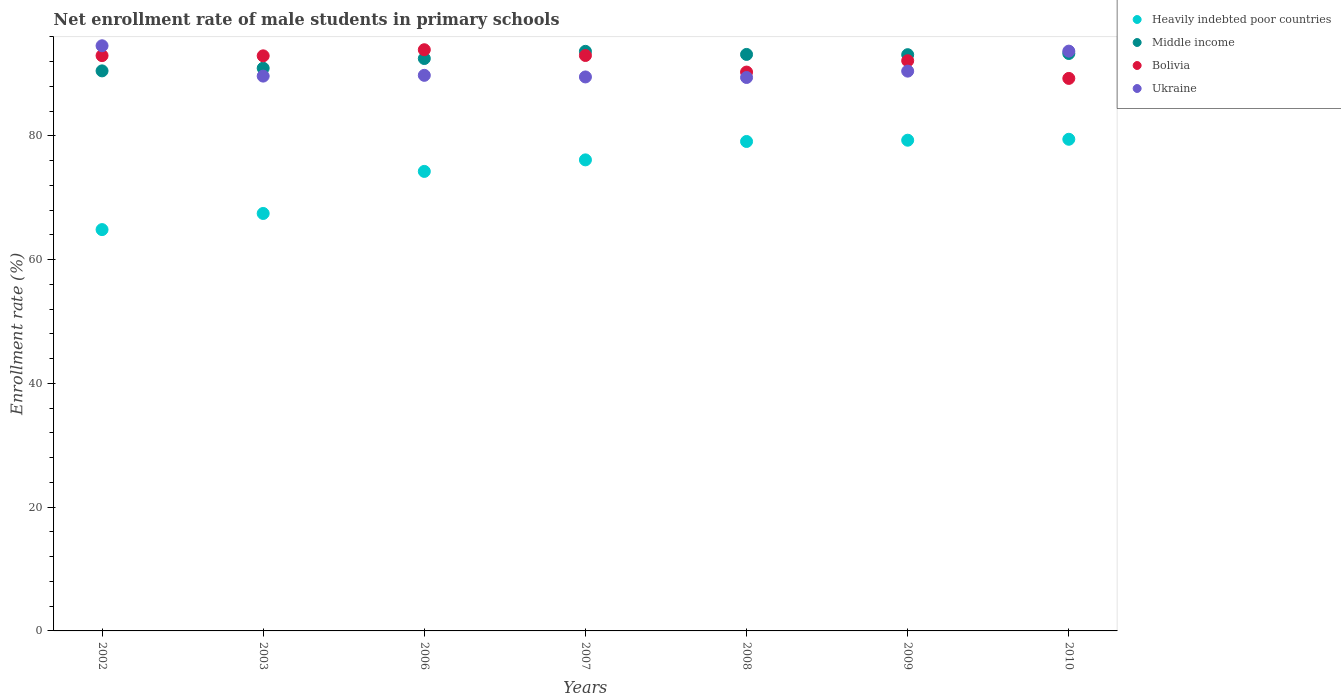How many different coloured dotlines are there?
Provide a succinct answer. 4. What is the net enrollment rate of male students in primary schools in Middle income in 2006?
Provide a short and direct response. 92.52. Across all years, what is the maximum net enrollment rate of male students in primary schools in Heavily indebted poor countries?
Your answer should be very brief. 79.46. Across all years, what is the minimum net enrollment rate of male students in primary schools in Heavily indebted poor countries?
Make the answer very short. 64.86. In which year was the net enrollment rate of male students in primary schools in Heavily indebted poor countries maximum?
Provide a succinct answer. 2010. What is the total net enrollment rate of male students in primary schools in Middle income in the graph?
Keep it short and to the point. 647.29. What is the difference between the net enrollment rate of male students in primary schools in Middle income in 2007 and that in 2008?
Your response must be concise. 0.5. What is the difference between the net enrollment rate of male students in primary schools in Ukraine in 2006 and the net enrollment rate of male students in primary schools in Bolivia in 2003?
Your response must be concise. -3.15. What is the average net enrollment rate of male students in primary schools in Bolivia per year?
Keep it short and to the point. 92.09. In the year 2006, what is the difference between the net enrollment rate of male students in primary schools in Heavily indebted poor countries and net enrollment rate of male students in primary schools in Middle income?
Offer a very short reply. -18.25. What is the ratio of the net enrollment rate of male students in primary schools in Middle income in 2009 to that in 2010?
Keep it short and to the point. 1. Is the net enrollment rate of male students in primary schools in Middle income in 2007 less than that in 2010?
Offer a very short reply. No. What is the difference between the highest and the second highest net enrollment rate of male students in primary schools in Bolivia?
Offer a very short reply. 0.93. What is the difference between the highest and the lowest net enrollment rate of male students in primary schools in Heavily indebted poor countries?
Provide a succinct answer. 14.6. In how many years, is the net enrollment rate of male students in primary schools in Middle income greater than the average net enrollment rate of male students in primary schools in Middle income taken over all years?
Offer a very short reply. 5. Is the sum of the net enrollment rate of male students in primary schools in Ukraine in 2002 and 2009 greater than the maximum net enrollment rate of male students in primary schools in Middle income across all years?
Offer a very short reply. Yes. Is it the case that in every year, the sum of the net enrollment rate of male students in primary schools in Middle income and net enrollment rate of male students in primary schools in Ukraine  is greater than the sum of net enrollment rate of male students in primary schools in Bolivia and net enrollment rate of male students in primary schools in Heavily indebted poor countries?
Offer a terse response. No. Is the net enrollment rate of male students in primary schools in Bolivia strictly less than the net enrollment rate of male students in primary schools in Middle income over the years?
Give a very brief answer. No. How many dotlines are there?
Your response must be concise. 4. What is the difference between two consecutive major ticks on the Y-axis?
Offer a very short reply. 20. Are the values on the major ticks of Y-axis written in scientific E-notation?
Your answer should be very brief. No. Does the graph contain grids?
Offer a very short reply. No. Where does the legend appear in the graph?
Provide a short and direct response. Top right. How many legend labels are there?
Your answer should be compact. 4. How are the legend labels stacked?
Keep it short and to the point. Vertical. What is the title of the graph?
Offer a terse response. Net enrollment rate of male students in primary schools. Does "Bolivia" appear as one of the legend labels in the graph?
Your answer should be compact. Yes. What is the label or title of the Y-axis?
Your answer should be very brief. Enrollment rate (%). What is the Enrollment rate (%) in Heavily indebted poor countries in 2002?
Your response must be concise. 64.86. What is the Enrollment rate (%) of Middle income in 2002?
Offer a terse response. 90.52. What is the Enrollment rate (%) of Bolivia in 2002?
Ensure brevity in your answer.  92.98. What is the Enrollment rate (%) of Ukraine in 2002?
Keep it short and to the point. 94.58. What is the Enrollment rate (%) in Heavily indebted poor countries in 2003?
Your answer should be compact. 67.47. What is the Enrollment rate (%) in Middle income in 2003?
Make the answer very short. 90.95. What is the Enrollment rate (%) in Bolivia in 2003?
Offer a very short reply. 92.95. What is the Enrollment rate (%) in Ukraine in 2003?
Make the answer very short. 89.67. What is the Enrollment rate (%) of Heavily indebted poor countries in 2006?
Your answer should be very brief. 74.27. What is the Enrollment rate (%) in Middle income in 2006?
Provide a succinct answer. 92.52. What is the Enrollment rate (%) in Bolivia in 2006?
Keep it short and to the point. 93.94. What is the Enrollment rate (%) in Ukraine in 2006?
Provide a short and direct response. 89.8. What is the Enrollment rate (%) in Heavily indebted poor countries in 2007?
Offer a very short reply. 76.13. What is the Enrollment rate (%) in Middle income in 2007?
Ensure brevity in your answer.  93.67. What is the Enrollment rate (%) in Bolivia in 2007?
Provide a short and direct response. 93.01. What is the Enrollment rate (%) of Ukraine in 2007?
Provide a succinct answer. 89.54. What is the Enrollment rate (%) of Heavily indebted poor countries in 2008?
Offer a terse response. 79.11. What is the Enrollment rate (%) of Middle income in 2008?
Ensure brevity in your answer.  93.18. What is the Enrollment rate (%) in Bolivia in 2008?
Provide a succinct answer. 90.33. What is the Enrollment rate (%) in Ukraine in 2008?
Make the answer very short. 89.45. What is the Enrollment rate (%) of Heavily indebted poor countries in 2009?
Make the answer very short. 79.31. What is the Enrollment rate (%) in Middle income in 2009?
Offer a very short reply. 93.14. What is the Enrollment rate (%) in Bolivia in 2009?
Your answer should be compact. 92.16. What is the Enrollment rate (%) of Ukraine in 2009?
Provide a succinct answer. 90.48. What is the Enrollment rate (%) in Heavily indebted poor countries in 2010?
Your answer should be compact. 79.46. What is the Enrollment rate (%) of Middle income in 2010?
Offer a very short reply. 93.33. What is the Enrollment rate (%) of Bolivia in 2010?
Provide a succinct answer. 89.3. What is the Enrollment rate (%) of Ukraine in 2010?
Keep it short and to the point. 93.71. Across all years, what is the maximum Enrollment rate (%) of Heavily indebted poor countries?
Your answer should be compact. 79.46. Across all years, what is the maximum Enrollment rate (%) of Middle income?
Provide a succinct answer. 93.67. Across all years, what is the maximum Enrollment rate (%) in Bolivia?
Make the answer very short. 93.94. Across all years, what is the maximum Enrollment rate (%) of Ukraine?
Offer a very short reply. 94.58. Across all years, what is the minimum Enrollment rate (%) in Heavily indebted poor countries?
Your answer should be very brief. 64.86. Across all years, what is the minimum Enrollment rate (%) in Middle income?
Offer a very short reply. 90.52. Across all years, what is the minimum Enrollment rate (%) of Bolivia?
Your answer should be very brief. 89.3. Across all years, what is the minimum Enrollment rate (%) of Ukraine?
Offer a very short reply. 89.45. What is the total Enrollment rate (%) of Heavily indebted poor countries in the graph?
Make the answer very short. 520.62. What is the total Enrollment rate (%) of Middle income in the graph?
Offer a very short reply. 647.29. What is the total Enrollment rate (%) in Bolivia in the graph?
Keep it short and to the point. 644.66. What is the total Enrollment rate (%) of Ukraine in the graph?
Keep it short and to the point. 637.22. What is the difference between the Enrollment rate (%) of Heavily indebted poor countries in 2002 and that in 2003?
Provide a short and direct response. -2.61. What is the difference between the Enrollment rate (%) of Middle income in 2002 and that in 2003?
Your answer should be compact. -0.43. What is the difference between the Enrollment rate (%) in Bolivia in 2002 and that in 2003?
Your response must be concise. 0.03. What is the difference between the Enrollment rate (%) of Ukraine in 2002 and that in 2003?
Offer a very short reply. 4.9. What is the difference between the Enrollment rate (%) in Heavily indebted poor countries in 2002 and that in 2006?
Offer a very short reply. -9.41. What is the difference between the Enrollment rate (%) of Middle income in 2002 and that in 2006?
Offer a terse response. -2. What is the difference between the Enrollment rate (%) in Bolivia in 2002 and that in 2006?
Your response must be concise. -0.95. What is the difference between the Enrollment rate (%) of Ukraine in 2002 and that in 2006?
Provide a short and direct response. 4.78. What is the difference between the Enrollment rate (%) of Heavily indebted poor countries in 2002 and that in 2007?
Ensure brevity in your answer.  -11.27. What is the difference between the Enrollment rate (%) in Middle income in 2002 and that in 2007?
Provide a succinct answer. -3.16. What is the difference between the Enrollment rate (%) in Bolivia in 2002 and that in 2007?
Your answer should be compact. -0.02. What is the difference between the Enrollment rate (%) in Ukraine in 2002 and that in 2007?
Keep it short and to the point. 5.04. What is the difference between the Enrollment rate (%) of Heavily indebted poor countries in 2002 and that in 2008?
Keep it short and to the point. -14.24. What is the difference between the Enrollment rate (%) of Middle income in 2002 and that in 2008?
Provide a short and direct response. -2.66. What is the difference between the Enrollment rate (%) of Bolivia in 2002 and that in 2008?
Your response must be concise. 2.66. What is the difference between the Enrollment rate (%) of Ukraine in 2002 and that in 2008?
Make the answer very short. 5.13. What is the difference between the Enrollment rate (%) of Heavily indebted poor countries in 2002 and that in 2009?
Ensure brevity in your answer.  -14.45. What is the difference between the Enrollment rate (%) of Middle income in 2002 and that in 2009?
Your response must be concise. -2.62. What is the difference between the Enrollment rate (%) in Bolivia in 2002 and that in 2009?
Offer a terse response. 0.82. What is the difference between the Enrollment rate (%) of Ukraine in 2002 and that in 2009?
Make the answer very short. 4.1. What is the difference between the Enrollment rate (%) in Heavily indebted poor countries in 2002 and that in 2010?
Give a very brief answer. -14.6. What is the difference between the Enrollment rate (%) in Middle income in 2002 and that in 2010?
Your response must be concise. -2.81. What is the difference between the Enrollment rate (%) in Bolivia in 2002 and that in 2010?
Make the answer very short. 3.68. What is the difference between the Enrollment rate (%) of Ukraine in 2002 and that in 2010?
Your answer should be compact. 0.87. What is the difference between the Enrollment rate (%) in Heavily indebted poor countries in 2003 and that in 2006?
Keep it short and to the point. -6.8. What is the difference between the Enrollment rate (%) in Middle income in 2003 and that in 2006?
Provide a short and direct response. -1.57. What is the difference between the Enrollment rate (%) of Bolivia in 2003 and that in 2006?
Provide a succinct answer. -0.99. What is the difference between the Enrollment rate (%) in Ukraine in 2003 and that in 2006?
Make the answer very short. -0.13. What is the difference between the Enrollment rate (%) in Heavily indebted poor countries in 2003 and that in 2007?
Make the answer very short. -8.66. What is the difference between the Enrollment rate (%) of Middle income in 2003 and that in 2007?
Your response must be concise. -2.73. What is the difference between the Enrollment rate (%) in Bolivia in 2003 and that in 2007?
Your response must be concise. -0.06. What is the difference between the Enrollment rate (%) of Ukraine in 2003 and that in 2007?
Provide a succinct answer. 0.14. What is the difference between the Enrollment rate (%) in Heavily indebted poor countries in 2003 and that in 2008?
Provide a short and direct response. -11.63. What is the difference between the Enrollment rate (%) in Middle income in 2003 and that in 2008?
Ensure brevity in your answer.  -2.23. What is the difference between the Enrollment rate (%) in Bolivia in 2003 and that in 2008?
Offer a very short reply. 2.62. What is the difference between the Enrollment rate (%) of Ukraine in 2003 and that in 2008?
Give a very brief answer. 0.22. What is the difference between the Enrollment rate (%) of Heavily indebted poor countries in 2003 and that in 2009?
Your response must be concise. -11.84. What is the difference between the Enrollment rate (%) of Middle income in 2003 and that in 2009?
Your answer should be very brief. -2.19. What is the difference between the Enrollment rate (%) of Bolivia in 2003 and that in 2009?
Ensure brevity in your answer.  0.79. What is the difference between the Enrollment rate (%) in Ukraine in 2003 and that in 2009?
Ensure brevity in your answer.  -0.8. What is the difference between the Enrollment rate (%) in Heavily indebted poor countries in 2003 and that in 2010?
Offer a very short reply. -11.99. What is the difference between the Enrollment rate (%) of Middle income in 2003 and that in 2010?
Provide a short and direct response. -2.38. What is the difference between the Enrollment rate (%) of Bolivia in 2003 and that in 2010?
Provide a short and direct response. 3.65. What is the difference between the Enrollment rate (%) in Ukraine in 2003 and that in 2010?
Give a very brief answer. -4.04. What is the difference between the Enrollment rate (%) of Heavily indebted poor countries in 2006 and that in 2007?
Offer a very short reply. -1.86. What is the difference between the Enrollment rate (%) in Middle income in 2006 and that in 2007?
Offer a very short reply. -1.16. What is the difference between the Enrollment rate (%) in Bolivia in 2006 and that in 2007?
Offer a terse response. 0.93. What is the difference between the Enrollment rate (%) of Ukraine in 2006 and that in 2007?
Your response must be concise. 0.26. What is the difference between the Enrollment rate (%) of Heavily indebted poor countries in 2006 and that in 2008?
Offer a very short reply. -4.84. What is the difference between the Enrollment rate (%) in Middle income in 2006 and that in 2008?
Your response must be concise. -0.66. What is the difference between the Enrollment rate (%) of Bolivia in 2006 and that in 2008?
Provide a succinct answer. 3.61. What is the difference between the Enrollment rate (%) in Ukraine in 2006 and that in 2008?
Your answer should be compact. 0.35. What is the difference between the Enrollment rate (%) in Heavily indebted poor countries in 2006 and that in 2009?
Offer a very short reply. -5.04. What is the difference between the Enrollment rate (%) in Middle income in 2006 and that in 2009?
Your answer should be very brief. -0.62. What is the difference between the Enrollment rate (%) in Bolivia in 2006 and that in 2009?
Offer a terse response. 1.78. What is the difference between the Enrollment rate (%) in Ukraine in 2006 and that in 2009?
Ensure brevity in your answer.  -0.68. What is the difference between the Enrollment rate (%) in Heavily indebted poor countries in 2006 and that in 2010?
Offer a terse response. -5.2. What is the difference between the Enrollment rate (%) in Middle income in 2006 and that in 2010?
Make the answer very short. -0.81. What is the difference between the Enrollment rate (%) of Bolivia in 2006 and that in 2010?
Your response must be concise. 4.63. What is the difference between the Enrollment rate (%) in Ukraine in 2006 and that in 2010?
Make the answer very short. -3.91. What is the difference between the Enrollment rate (%) of Heavily indebted poor countries in 2007 and that in 2008?
Your answer should be compact. -2.97. What is the difference between the Enrollment rate (%) in Middle income in 2007 and that in 2008?
Make the answer very short. 0.5. What is the difference between the Enrollment rate (%) of Bolivia in 2007 and that in 2008?
Give a very brief answer. 2.68. What is the difference between the Enrollment rate (%) in Ukraine in 2007 and that in 2008?
Ensure brevity in your answer.  0.09. What is the difference between the Enrollment rate (%) of Heavily indebted poor countries in 2007 and that in 2009?
Ensure brevity in your answer.  -3.18. What is the difference between the Enrollment rate (%) of Middle income in 2007 and that in 2009?
Ensure brevity in your answer.  0.54. What is the difference between the Enrollment rate (%) of Bolivia in 2007 and that in 2009?
Give a very brief answer. 0.84. What is the difference between the Enrollment rate (%) in Ukraine in 2007 and that in 2009?
Make the answer very short. -0.94. What is the difference between the Enrollment rate (%) of Heavily indebted poor countries in 2007 and that in 2010?
Your response must be concise. -3.33. What is the difference between the Enrollment rate (%) in Middle income in 2007 and that in 2010?
Your response must be concise. 0.35. What is the difference between the Enrollment rate (%) of Bolivia in 2007 and that in 2010?
Give a very brief answer. 3.7. What is the difference between the Enrollment rate (%) of Ukraine in 2007 and that in 2010?
Offer a very short reply. -4.17. What is the difference between the Enrollment rate (%) of Heavily indebted poor countries in 2008 and that in 2009?
Provide a succinct answer. -0.21. What is the difference between the Enrollment rate (%) of Middle income in 2008 and that in 2009?
Your answer should be very brief. 0.04. What is the difference between the Enrollment rate (%) of Bolivia in 2008 and that in 2009?
Provide a short and direct response. -1.84. What is the difference between the Enrollment rate (%) of Ukraine in 2008 and that in 2009?
Keep it short and to the point. -1.03. What is the difference between the Enrollment rate (%) of Heavily indebted poor countries in 2008 and that in 2010?
Your answer should be compact. -0.36. What is the difference between the Enrollment rate (%) of Middle income in 2008 and that in 2010?
Provide a succinct answer. -0.15. What is the difference between the Enrollment rate (%) in Bolivia in 2008 and that in 2010?
Provide a short and direct response. 1.02. What is the difference between the Enrollment rate (%) of Ukraine in 2008 and that in 2010?
Ensure brevity in your answer.  -4.26. What is the difference between the Enrollment rate (%) in Heavily indebted poor countries in 2009 and that in 2010?
Offer a terse response. -0.15. What is the difference between the Enrollment rate (%) of Middle income in 2009 and that in 2010?
Make the answer very short. -0.19. What is the difference between the Enrollment rate (%) in Bolivia in 2009 and that in 2010?
Ensure brevity in your answer.  2.86. What is the difference between the Enrollment rate (%) in Ukraine in 2009 and that in 2010?
Provide a succinct answer. -3.23. What is the difference between the Enrollment rate (%) of Heavily indebted poor countries in 2002 and the Enrollment rate (%) of Middle income in 2003?
Provide a succinct answer. -26.08. What is the difference between the Enrollment rate (%) in Heavily indebted poor countries in 2002 and the Enrollment rate (%) in Bolivia in 2003?
Your answer should be compact. -28.08. What is the difference between the Enrollment rate (%) of Heavily indebted poor countries in 2002 and the Enrollment rate (%) of Ukraine in 2003?
Give a very brief answer. -24.81. What is the difference between the Enrollment rate (%) of Middle income in 2002 and the Enrollment rate (%) of Bolivia in 2003?
Make the answer very short. -2.43. What is the difference between the Enrollment rate (%) in Middle income in 2002 and the Enrollment rate (%) in Ukraine in 2003?
Your answer should be very brief. 0.84. What is the difference between the Enrollment rate (%) of Bolivia in 2002 and the Enrollment rate (%) of Ukraine in 2003?
Make the answer very short. 3.31. What is the difference between the Enrollment rate (%) in Heavily indebted poor countries in 2002 and the Enrollment rate (%) in Middle income in 2006?
Offer a very short reply. -27.65. What is the difference between the Enrollment rate (%) of Heavily indebted poor countries in 2002 and the Enrollment rate (%) of Bolivia in 2006?
Give a very brief answer. -29.07. What is the difference between the Enrollment rate (%) in Heavily indebted poor countries in 2002 and the Enrollment rate (%) in Ukraine in 2006?
Provide a succinct answer. -24.93. What is the difference between the Enrollment rate (%) of Middle income in 2002 and the Enrollment rate (%) of Bolivia in 2006?
Provide a short and direct response. -3.42. What is the difference between the Enrollment rate (%) of Middle income in 2002 and the Enrollment rate (%) of Ukraine in 2006?
Offer a terse response. 0.72. What is the difference between the Enrollment rate (%) in Bolivia in 2002 and the Enrollment rate (%) in Ukraine in 2006?
Provide a short and direct response. 3.18. What is the difference between the Enrollment rate (%) in Heavily indebted poor countries in 2002 and the Enrollment rate (%) in Middle income in 2007?
Make the answer very short. -28.81. What is the difference between the Enrollment rate (%) of Heavily indebted poor countries in 2002 and the Enrollment rate (%) of Bolivia in 2007?
Keep it short and to the point. -28.14. What is the difference between the Enrollment rate (%) in Heavily indebted poor countries in 2002 and the Enrollment rate (%) in Ukraine in 2007?
Provide a succinct answer. -24.67. What is the difference between the Enrollment rate (%) of Middle income in 2002 and the Enrollment rate (%) of Bolivia in 2007?
Ensure brevity in your answer.  -2.49. What is the difference between the Enrollment rate (%) of Middle income in 2002 and the Enrollment rate (%) of Ukraine in 2007?
Offer a very short reply. 0.98. What is the difference between the Enrollment rate (%) of Bolivia in 2002 and the Enrollment rate (%) of Ukraine in 2007?
Provide a succinct answer. 3.44. What is the difference between the Enrollment rate (%) in Heavily indebted poor countries in 2002 and the Enrollment rate (%) in Middle income in 2008?
Provide a succinct answer. -28.31. What is the difference between the Enrollment rate (%) in Heavily indebted poor countries in 2002 and the Enrollment rate (%) in Bolivia in 2008?
Provide a succinct answer. -25.46. What is the difference between the Enrollment rate (%) in Heavily indebted poor countries in 2002 and the Enrollment rate (%) in Ukraine in 2008?
Offer a very short reply. -24.59. What is the difference between the Enrollment rate (%) in Middle income in 2002 and the Enrollment rate (%) in Bolivia in 2008?
Give a very brief answer. 0.19. What is the difference between the Enrollment rate (%) in Middle income in 2002 and the Enrollment rate (%) in Ukraine in 2008?
Your answer should be compact. 1.07. What is the difference between the Enrollment rate (%) of Bolivia in 2002 and the Enrollment rate (%) of Ukraine in 2008?
Make the answer very short. 3.53. What is the difference between the Enrollment rate (%) in Heavily indebted poor countries in 2002 and the Enrollment rate (%) in Middle income in 2009?
Your answer should be compact. -28.27. What is the difference between the Enrollment rate (%) in Heavily indebted poor countries in 2002 and the Enrollment rate (%) in Bolivia in 2009?
Keep it short and to the point. -27.3. What is the difference between the Enrollment rate (%) in Heavily indebted poor countries in 2002 and the Enrollment rate (%) in Ukraine in 2009?
Your response must be concise. -25.61. What is the difference between the Enrollment rate (%) in Middle income in 2002 and the Enrollment rate (%) in Bolivia in 2009?
Make the answer very short. -1.64. What is the difference between the Enrollment rate (%) of Middle income in 2002 and the Enrollment rate (%) of Ukraine in 2009?
Your response must be concise. 0.04. What is the difference between the Enrollment rate (%) in Bolivia in 2002 and the Enrollment rate (%) in Ukraine in 2009?
Ensure brevity in your answer.  2.5. What is the difference between the Enrollment rate (%) of Heavily indebted poor countries in 2002 and the Enrollment rate (%) of Middle income in 2010?
Make the answer very short. -28.46. What is the difference between the Enrollment rate (%) in Heavily indebted poor countries in 2002 and the Enrollment rate (%) in Bolivia in 2010?
Provide a succinct answer. -24.44. What is the difference between the Enrollment rate (%) of Heavily indebted poor countries in 2002 and the Enrollment rate (%) of Ukraine in 2010?
Provide a short and direct response. -28.85. What is the difference between the Enrollment rate (%) of Middle income in 2002 and the Enrollment rate (%) of Bolivia in 2010?
Offer a terse response. 1.22. What is the difference between the Enrollment rate (%) in Middle income in 2002 and the Enrollment rate (%) in Ukraine in 2010?
Your answer should be compact. -3.19. What is the difference between the Enrollment rate (%) in Bolivia in 2002 and the Enrollment rate (%) in Ukraine in 2010?
Your response must be concise. -0.73. What is the difference between the Enrollment rate (%) in Heavily indebted poor countries in 2003 and the Enrollment rate (%) in Middle income in 2006?
Offer a terse response. -25.04. What is the difference between the Enrollment rate (%) in Heavily indebted poor countries in 2003 and the Enrollment rate (%) in Bolivia in 2006?
Provide a succinct answer. -26.46. What is the difference between the Enrollment rate (%) of Heavily indebted poor countries in 2003 and the Enrollment rate (%) of Ukraine in 2006?
Offer a very short reply. -22.33. What is the difference between the Enrollment rate (%) of Middle income in 2003 and the Enrollment rate (%) of Bolivia in 2006?
Your response must be concise. -2.99. What is the difference between the Enrollment rate (%) in Middle income in 2003 and the Enrollment rate (%) in Ukraine in 2006?
Offer a very short reply. 1.15. What is the difference between the Enrollment rate (%) of Bolivia in 2003 and the Enrollment rate (%) of Ukraine in 2006?
Give a very brief answer. 3.15. What is the difference between the Enrollment rate (%) in Heavily indebted poor countries in 2003 and the Enrollment rate (%) in Middle income in 2007?
Your answer should be compact. -26.2. What is the difference between the Enrollment rate (%) of Heavily indebted poor countries in 2003 and the Enrollment rate (%) of Bolivia in 2007?
Your answer should be compact. -25.53. What is the difference between the Enrollment rate (%) in Heavily indebted poor countries in 2003 and the Enrollment rate (%) in Ukraine in 2007?
Your answer should be compact. -22.07. What is the difference between the Enrollment rate (%) in Middle income in 2003 and the Enrollment rate (%) in Bolivia in 2007?
Keep it short and to the point. -2.06. What is the difference between the Enrollment rate (%) of Middle income in 2003 and the Enrollment rate (%) of Ukraine in 2007?
Provide a succinct answer. 1.41. What is the difference between the Enrollment rate (%) in Bolivia in 2003 and the Enrollment rate (%) in Ukraine in 2007?
Offer a terse response. 3.41. What is the difference between the Enrollment rate (%) of Heavily indebted poor countries in 2003 and the Enrollment rate (%) of Middle income in 2008?
Give a very brief answer. -25.71. What is the difference between the Enrollment rate (%) of Heavily indebted poor countries in 2003 and the Enrollment rate (%) of Bolivia in 2008?
Your response must be concise. -22.85. What is the difference between the Enrollment rate (%) in Heavily indebted poor countries in 2003 and the Enrollment rate (%) in Ukraine in 2008?
Provide a short and direct response. -21.98. What is the difference between the Enrollment rate (%) of Middle income in 2003 and the Enrollment rate (%) of Bolivia in 2008?
Offer a terse response. 0.62. What is the difference between the Enrollment rate (%) of Middle income in 2003 and the Enrollment rate (%) of Ukraine in 2008?
Provide a short and direct response. 1.5. What is the difference between the Enrollment rate (%) of Bolivia in 2003 and the Enrollment rate (%) of Ukraine in 2008?
Give a very brief answer. 3.5. What is the difference between the Enrollment rate (%) of Heavily indebted poor countries in 2003 and the Enrollment rate (%) of Middle income in 2009?
Your response must be concise. -25.66. What is the difference between the Enrollment rate (%) of Heavily indebted poor countries in 2003 and the Enrollment rate (%) of Bolivia in 2009?
Your answer should be compact. -24.69. What is the difference between the Enrollment rate (%) in Heavily indebted poor countries in 2003 and the Enrollment rate (%) in Ukraine in 2009?
Give a very brief answer. -23. What is the difference between the Enrollment rate (%) of Middle income in 2003 and the Enrollment rate (%) of Bolivia in 2009?
Your response must be concise. -1.21. What is the difference between the Enrollment rate (%) of Middle income in 2003 and the Enrollment rate (%) of Ukraine in 2009?
Your response must be concise. 0.47. What is the difference between the Enrollment rate (%) of Bolivia in 2003 and the Enrollment rate (%) of Ukraine in 2009?
Offer a terse response. 2.47. What is the difference between the Enrollment rate (%) of Heavily indebted poor countries in 2003 and the Enrollment rate (%) of Middle income in 2010?
Keep it short and to the point. -25.86. What is the difference between the Enrollment rate (%) in Heavily indebted poor countries in 2003 and the Enrollment rate (%) in Bolivia in 2010?
Keep it short and to the point. -21.83. What is the difference between the Enrollment rate (%) in Heavily indebted poor countries in 2003 and the Enrollment rate (%) in Ukraine in 2010?
Your response must be concise. -26.24. What is the difference between the Enrollment rate (%) of Middle income in 2003 and the Enrollment rate (%) of Bolivia in 2010?
Offer a terse response. 1.65. What is the difference between the Enrollment rate (%) of Middle income in 2003 and the Enrollment rate (%) of Ukraine in 2010?
Your response must be concise. -2.76. What is the difference between the Enrollment rate (%) of Bolivia in 2003 and the Enrollment rate (%) of Ukraine in 2010?
Offer a very short reply. -0.76. What is the difference between the Enrollment rate (%) in Heavily indebted poor countries in 2006 and the Enrollment rate (%) in Middle income in 2007?
Offer a terse response. -19.4. What is the difference between the Enrollment rate (%) in Heavily indebted poor countries in 2006 and the Enrollment rate (%) in Bolivia in 2007?
Your response must be concise. -18.74. What is the difference between the Enrollment rate (%) of Heavily indebted poor countries in 2006 and the Enrollment rate (%) of Ukraine in 2007?
Give a very brief answer. -15.27. What is the difference between the Enrollment rate (%) of Middle income in 2006 and the Enrollment rate (%) of Bolivia in 2007?
Offer a terse response. -0.49. What is the difference between the Enrollment rate (%) of Middle income in 2006 and the Enrollment rate (%) of Ukraine in 2007?
Ensure brevity in your answer.  2.98. What is the difference between the Enrollment rate (%) of Bolivia in 2006 and the Enrollment rate (%) of Ukraine in 2007?
Give a very brief answer. 4.4. What is the difference between the Enrollment rate (%) of Heavily indebted poor countries in 2006 and the Enrollment rate (%) of Middle income in 2008?
Keep it short and to the point. -18.91. What is the difference between the Enrollment rate (%) of Heavily indebted poor countries in 2006 and the Enrollment rate (%) of Bolivia in 2008?
Offer a terse response. -16.06. What is the difference between the Enrollment rate (%) of Heavily indebted poor countries in 2006 and the Enrollment rate (%) of Ukraine in 2008?
Ensure brevity in your answer.  -15.18. What is the difference between the Enrollment rate (%) of Middle income in 2006 and the Enrollment rate (%) of Bolivia in 2008?
Your response must be concise. 2.19. What is the difference between the Enrollment rate (%) in Middle income in 2006 and the Enrollment rate (%) in Ukraine in 2008?
Your answer should be very brief. 3.07. What is the difference between the Enrollment rate (%) in Bolivia in 2006 and the Enrollment rate (%) in Ukraine in 2008?
Your answer should be very brief. 4.49. What is the difference between the Enrollment rate (%) of Heavily indebted poor countries in 2006 and the Enrollment rate (%) of Middle income in 2009?
Offer a terse response. -18.87. What is the difference between the Enrollment rate (%) of Heavily indebted poor countries in 2006 and the Enrollment rate (%) of Bolivia in 2009?
Your response must be concise. -17.89. What is the difference between the Enrollment rate (%) of Heavily indebted poor countries in 2006 and the Enrollment rate (%) of Ukraine in 2009?
Make the answer very short. -16.21. What is the difference between the Enrollment rate (%) of Middle income in 2006 and the Enrollment rate (%) of Bolivia in 2009?
Ensure brevity in your answer.  0.36. What is the difference between the Enrollment rate (%) of Middle income in 2006 and the Enrollment rate (%) of Ukraine in 2009?
Ensure brevity in your answer.  2.04. What is the difference between the Enrollment rate (%) of Bolivia in 2006 and the Enrollment rate (%) of Ukraine in 2009?
Ensure brevity in your answer.  3.46. What is the difference between the Enrollment rate (%) in Heavily indebted poor countries in 2006 and the Enrollment rate (%) in Middle income in 2010?
Make the answer very short. -19.06. What is the difference between the Enrollment rate (%) in Heavily indebted poor countries in 2006 and the Enrollment rate (%) in Bolivia in 2010?
Offer a terse response. -15.03. What is the difference between the Enrollment rate (%) of Heavily indebted poor countries in 2006 and the Enrollment rate (%) of Ukraine in 2010?
Your response must be concise. -19.44. What is the difference between the Enrollment rate (%) in Middle income in 2006 and the Enrollment rate (%) in Bolivia in 2010?
Your answer should be very brief. 3.21. What is the difference between the Enrollment rate (%) in Middle income in 2006 and the Enrollment rate (%) in Ukraine in 2010?
Provide a short and direct response. -1.19. What is the difference between the Enrollment rate (%) in Bolivia in 2006 and the Enrollment rate (%) in Ukraine in 2010?
Provide a short and direct response. 0.23. What is the difference between the Enrollment rate (%) in Heavily indebted poor countries in 2007 and the Enrollment rate (%) in Middle income in 2008?
Keep it short and to the point. -17.04. What is the difference between the Enrollment rate (%) of Heavily indebted poor countries in 2007 and the Enrollment rate (%) of Bolivia in 2008?
Ensure brevity in your answer.  -14.19. What is the difference between the Enrollment rate (%) of Heavily indebted poor countries in 2007 and the Enrollment rate (%) of Ukraine in 2008?
Your answer should be very brief. -13.32. What is the difference between the Enrollment rate (%) in Middle income in 2007 and the Enrollment rate (%) in Bolivia in 2008?
Ensure brevity in your answer.  3.35. What is the difference between the Enrollment rate (%) of Middle income in 2007 and the Enrollment rate (%) of Ukraine in 2008?
Your answer should be compact. 4.22. What is the difference between the Enrollment rate (%) in Bolivia in 2007 and the Enrollment rate (%) in Ukraine in 2008?
Make the answer very short. 3.56. What is the difference between the Enrollment rate (%) of Heavily indebted poor countries in 2007 and the Enrollment rate (%) of Middle income in 2009?
Ensure brevity in your answer.  -17. What is the difference between the Enrollment rate (%) in Heavily indebted poor countries in 2007 and the Enrollment rate (%) in Bolivia in 2009?
Ensure brevity in your answer.  -16.03. What is the difference between the Enrollment rate (%) of Heavily indebted poor countries in 2007 and the Enrollment rate (%) of Ukraine in 2009?
Provide a succinct answer. -14.34. What is the difference between the Enrollment rate (%) of Middle income in 2007 and the Enrollment rate (%) of Bolivia in 2009?
Give a very brief answer. 1.51. What is the difference between the Enrollment rate (%) in Middle income in 2007 and the Enrollment rate (%) in Ukraine in 2009?
Make the answer very short. 3.2. What is the difference between the Enrollment rate (%) of Bolivia in 2007 and the Enrollment rate (%) of Ukraine in 2009?
Make the answer very short. 2.53. What is the difference between the Enrollment rate (%) of Heavily indebted poor countries in 2007 and the Enrollment rate (%) of Middle income in 2010?
Provide a succinct answer. -17.19. What is the difference between the Enrollment rate (%) of Heavily indebted poor countries in 2007 and the Enrollment rate (%) of Bolivia in 2010?
Your answer should be compact. -13.17. What is the difference between the Enrollment rate (%) in Heavily indebted poor countries in 2007 and the Enrollment rate (%) in Ukraine in 2010?
Provide a succinct answer. -17.57. What is the difference between the Enrollment rate (%) in Middle income in 2007 and the Enrollment rate (%) in Bolivia in 2010?
Provide a succinct answer. 4.37. What is the difference between the Enrollment rate (%) of Middle income in 2007 and the Enrollment rate (%) of Ukraine in 2010?
Provide a short and direct response. -0.04. What is the difference between the Enrollment rate (%) in Bolivia in 2007 and the Enrollment rate (%) in Ukraine in 2010?
Offer a very short reply. -0.7. What is the difference between the Enrollment rate (%) in Heavily indebted poor countries in 2008 and the Enrollment rate (%) in Middle income in 2009?
Offer a very short reply. -14.03. What is the difference between the Enrollment rate (%) in Heavily indebted poor countries in 2008 and the Enrollment rate (%) in Bolivia in 2009?
Your answer should be very brief. -13.05. What is the difference between the Enrollment rate (%) of Heavily indebted poor countries in 2008 and the Enrollment rate (%) of Ukraine in 2009?
Offer a very short reply. -11.37. What is the difference between the Enrollment rate (%) in Middle income in 2008 and the Enrollment rate (%) in Bolivia in 2009?
Give a very brief answer. 1.02. What is the difference between the Enrollment rate (%) of Middle income in 2008 and the Enrollment rate (%) of Ukraine in 2009?
Your answer should be compact. 2.7. What is the difference between the Enrollment rate (%) of Bolivia in 2008 and the Enrollment rate (%) of Ukraine in 2009?
Offer a very short reply. -0.15. What is the difference between the Enrollment rate (%) in Heavily indebted poor countries in 2008 and the Enrollment rate (%) in Middle income in 2010?
Keep it short and to the point. -14.22. What is the difference between the Enrollment rate (%) in Heavily indebted poor countries in 2008 and the Enrollment rate (%) in Bolivia in 2010?
Give a very brief answer. -10.19. What is the difference between the Enrollment rate (%) of Heavily indebted poor countries in 2008 and the Enrollment rate (%) of Ukraine in 2010?
Offer a terse response. -14.6. What is the difference between the Enrollment rate (%) of Middle income in 2008 and the Enrollment rate (%) of Bolivia in 2010?
Provide a short and direct response. 3.88. What is the difference between the Enrollment rate (%) in Middle income in 2008 and the Enrollment rate (%) in Ukraine in 2010?
Provide a succinct answer. -0.53. What is the difference between the Enrollment rate (%) in Bolivia in 2008 and the Enrollment rate (%) in Ukraine in 2010?
Your response must be concise. -3.38. What is the difference between the Enrollment rate (%) in Heavily indebted poor countries in 2009 and the Enrollment rate (%) in Middle income in 2010?
Your response must be concise. -14.02. What is the difference between the Enrollment rate (%) of Heavily indebted poor countries in 2009 and the Enrollment rate (%) of Bolivia in 2010?
Ensure brevity in your answer.  -9.99. What is the difference between the Enrollment rate (%) of Heavily indebted poor countries in 2009 and the Enrollment rate (%) of Ukraine in 2010?
Provide a short and direct response. -14.4. What is the difference between the Enrollment rate (%) in Middle income in 2009 and the Enrollment rate (%) in Bolivia in 2010?
Ensure brevity in your answer.  3.83. What is the difference between the Enrollment rate (%) of Middle income in 2009 and the Enrollment rate (%) of Ukraine in 2010?
Make the answer very short. -0.57. What is the difference between the Enrollment rate (%) in Bolivia in 2009 and the Enrollment rate (%) in Ukraine in 2010?
Provide a succinct answer. -1.55. What is the average Enrollment rate (%) in Heavily indebted poor countries per year?
Your answer should be compact. 74.37. What is the average Enrollment rate (%) of Middle income per year?
Provide a short and direct response. 92.47. What is the average Enrollment rate (%) in Bolivia per year?
Your response must be concise. 92.09. What is the average Enrollment rate (%) in Ukraine per year?
Your response must be concise. 91.03. In the year 2002, what is the difference between the Enrollment rate (%) of Heavily indebted poor countries and Enrollment rate (%) of Middle income?
Keep it short and to the point. -25.65. In the year 2002, what is the difference between the Enrollment rate (%) of Heavily indebted poor countries and Enrollment rate (%) of Bolivia?
Your answer should be compact. -28.12. In the year 2002, what is the difference between the Enrollment rate (%) in Heavily indebted poor countries and Enrollment rate (%) in Ukraine?
Keep it short and to the point. -29.71. In the year 2002, what is the difference between the Enrollment rate (%) in Middle income and Enrollment rate (%) in Bolivia?
Make the answer very short. -2.46. In the year 2002, what is the difference between the Enrollment rate (%) in Middle income and Enrollment rate (%) in Ukraine?
Your answer should be compact. -4.06. In the year 2002, what is the difference between the Enrollment rate (%) of Bolivia and Enrollment rate (%) of Ukraine?
Your answer should be compact. -1.6. In the year 2003, what is the difference between the Enrollment rate (%) in Heavily indebted poor countries and Enrollment rate (%) in Middle income?
Make the answer very short. -23.48. In the year 2003, what is the difference between the Enrollment rate (%) in Heavily indebted poor countries and Enrollment rate (%) in Bolivia?
Provide a succinct answer. -25.48. In the year 2003, what is the difference between the Enrollment rate (%) of Heavily indebted poor countries and Enrollment rate (%) of Ukraine?
Ensure brevity in your answer.  -22.2. In the year 2003, what is the difference between the Enrollment rate (%) in Middle income and Enrollment rate (%) in Bolivia?
Offer a terse response. -2. In the year 2003, what is the difference between the Enrollment rate (%) in Middle income and Enrollment rate (%) in Ukraine?
Offer a terse response. 1.28. In the year 2003, what is the difference between the Enrollment rate (%) of Bolivia and Enrollment rate (%) of Ukraine?
Provide a short and direct response. 3.28. In the year 2006, what is the difference between the Enrollment rate (%) in Heavily indebted poor countries and Enrollment rate (%) in Middle income?
Provide a short and direct response. -18.25. In the year 2006, what is the difference between the Enrollment rate (%) in Heavily indebted poor countries and Enrollment rate (%) in Bolivia?
Provide a succinct answer. -19.67. In the year 2006, what is the difference between the Enrollment rate (%) in Heavily indebted poor countries and Enrollment rate (%) in Ukraine?
Offer a very short reply. -15.53. In the year 2006, what is the difference between the Enrollment rate (%) in Middle income and Enrollment rate (%) in Bolivia?
Offer a very short reply. -1.42. In the year 2006, what is the difference between the Enrollment rate (%) in Middle income and Enrollment rate (%) in Ukraine?
Your answer should be compact. 2.72. In the year 2006, what is the difference between the Enrollment rate (%) in Bolivia and Enrollment rate (%) in Ukraine?
Your answer should be very brief. 4.14. In the year 2007, what is the difference between the Enrollment rate (%) in Heavily indebted poor countries and Enrollment rate (%) in Middle income?
Ensure brevity in your answer.  -17.54. In the year 2007, what is the difference between the Enrollment rate (%) in Heavily indebted poor countries and Enrollment rate (%) in Bolivia?
Offer a terse response. -16.87. In the year 2007, what is the difference between the Enrollment rate (%) of Heavily indebted poor countries and Enrollment rate (%) of Ukraine?
Offer a very short reply. -13.4. In the year 2007, what is the difference between the Enrollment rate (%) in Middle income and Enrollment rate (%) in Bolivia?
Offer a terse response. 0.67. In the year 2007, what is the difference between the Enrollment rate (%) in Middle income and Enrollment rate (%) in Ukraine?
Keep it short and to the point. 4.14. In the year 2007, what is the difference between the Enrollment rate (%) of Bolivia and Enrollment rate (%) of Ukraine?
Give a very brief answer. 3.47. In the year 2008, what is the difference between the Enrollment rate (%) of Heavily indebted poor countries and Enrollment rate (%) of Middle income?
Your answer should be compact. -14.07. In the year 2008, what is the difference between the Enrollment rate (%) of Heavily indebted poor countries and Enrollment rate (%) of Bolivia?
Ensure brevity in your answer.  -11.22. In the year 2008, what is the difference between the Enrollment rate (%) of Heavily indebted poor countries and Enrollment rate (%) of Ukraine?
Give a very brief answer. -10.34. In the year 2008, what is the difference between the Enrollment rate (%) of Middle income and Enrollment rate (%) of Bolivia?
Provide a succinct answer. 2.85. In the year 2008, what is the difference between the Enrollment rate (%) in Middle income and Enrollment rate (%) in Ukraine?
Give a very brief answer. 3.73. In the year 2008, what is the difference between the Enrollment rate (%) in Bolivia and Enrollment rate (%) in Ukraine?
Offer a very short reply. 0.88. In the year 2009, what is the difference between the Enrollment rate (%) in Heavily indebted poor countries and Enrollment rate (%) in Middle income?
Offer a very short reply. -13.82. In the year 2009, what is the difference between the Enrollment rate (%) of Heavily indebted poor countries and Enrollment rate (%) of Bolivia?
Offer a very short reply. -12.85. In the year 2009, what is the difference between the Enrollment rate (%) of Heavily indebted poor countries and Enrollment rate (%) of Ukraine?
Make the answer very short. -11.16. In the year 2009, what is the difference between the Enrollment rate (%) of Middle income and Enrollment rate (%) of Bolivia?
Your answer should be very brief. 0.98. In the year 2009, what is the difference between the Enrollment rate (%) in Middle income and Enrollment rate (%) in Ukraine?
Offer a terse response. 2.66. In the year 2009, what is the difference between the Enrollment rate (%) of Bolivia and Enrollment rate (%) of Ukraine?
Offer a terse response. 1.68. In the year 2010, what is the difference between the Enrollment rate (%) of Heavily indebted poor countries and Enrollment rate (%) of Middle income?
Your answer should be very brief. -13.86. In the year 2010, what is the difference between the Enrollment rate (%) in Heavily indebted poor countries and Enrollment rate (%) in Bolivia?
Make the answer very short. -9.84. In the year 2010, what is the difference between the Enrollment rate (%) in Heavily indebted poor countries and Enrollment rate (%) in Ukraine?
Give a very brief answer. -14.24. In the year 2010, what is the difference between the Enrollment rate (%) in Middle income and Enrollment rate (%) in Bolivia?
Your answer should be very brief. 4.03. In the year 2010, what is the difference between the Enrollment rate (%) in Middle income and Enrollment rate (%) in Ukraine?
Offer a very short reply. -0.38. In the year 2010, what is the difference between the Enrollment rate (%) in Bolivia and Enrollment rate (%) in Ukraine?
Offer a terse response. -4.41. What is the ratio of the Enrollment rate (%) in Heavily indebted poor countries in 2002 to that in 2003?
Provide a short and direct response. 0.96. What is the ratio of the Enrollment rate (%) of Middle income in 2002 to that in 2003?
Your answer should be very brief. 1. What is the ratio of the Enrollment rate (%) in Ukraine in 2002 to that in 2003?
Keep it short and to the point. 1.05. What is the ratio of the Enrollment rate (%) in Heavily indebted poor countries in 2002 to that in 2006?
Ensure brevity in your answer.  0.87. What is the ratio of the Enrollment rate (%) in Middle income in 2002 to that in 2006?
Your answer should be very brief. 0.98. What is the ratio of the Enrollment rate (%) of Bolivia in 2002 to that in 2006?
Ensure brevity in your answer.  0.99. What is the ratio of the Enrollment rate (%) of Ukraine in 2002 to that in 2006?
Your response must be concise. 1.05. What is the ratio of the Enrollment rate (%) in Heavily indebted poor countries in 2002 to that in 2007?
Your response must be concise. 0.85. What is the ratio of the Enrollment rate (%) in Middle income in 2002 to that in 2007?
Give a very brief answer. 0.97. What is the ratio of the Enrollment rate (%) of Bolivia in 2002 to that in 2007?
Your response must be concise. 1. What is the ratio of the Enrollment rate (%) in Ukraine in 2002 to that in 2007?
Your answer should be compact. 1.06. What is the ratio of the Enrollment rate (%) in Heavily indebted poor countries in 2002 to that in 2008?
Your response must be concise. 0.82. What is the ratio of the Enrollment rate (%) in Middle income in 2002 to that in 2008?
Give a very brief answer. 0.97. What is the ratio of the Enrollment rate (%) in Bolivia in 2002 to that in 2008?
Keep it short and to the point. 1.03. What is the ratio of the Enrollment rate (%) in Ukraine in 2002 to that in 2008?
Ensure brevity in your answer.  1.06. What is the ratio of the Enrollment rate (%) in Heavily indebted poor countries in 2002 to that in 2009?
Keep it short and to the point. 0.82. What is the ratio of the Enrollment rate (%) in Middle income in 2002 to that in 2009?
Your answer should be very brief. 0.97. What is the ratio of the Enrollment rate (%) of Bolivia in 2002 to that in 2009?
Offer a very short reply. 1.01. What is the ratio of the Enrollment rate (%) of Ukraine in 2002 to that in 2009?
Give a very brief answer. 1.05. What is the ratio of the Enrollment rate (%) of Heavily indebted poor countries in 2002 to that in 2010?
Give a very brief answer. 0.82. What is the ratio of the Enrollment rate (%) in Middle income in 2002 to that in 2010?
Your answer should be compact. 0.97. What is the ratio of the Enrollment rate (%) of Bolivia in 2002 to that in 2010?
Your answer should be very brief. 1.04. What is the ratio of the Enrollment rate (%) in Ukraine in 2002 to that in 2010?
Your answer should be compact. 1.01. What is the ratio of the Enrollment rate (%) in Heavily indebted poor countries in 2003 to that in 2006?
Your response must be concise. 0.91. What is the ratio of the Enrollment rate (%) in Middle income in 2003 to that in 2006?
Your answer should be very brief. 0.98. What is the ratio of the Enrollment rate (%) in Heavily indebted poor countries in 2003 to that in 2007?
Your answer should be compact. 0.89. What is the ratio of the Enrollment rate (%) in Middle income in 2003 to that in 2007?
Your answer should be very brief. 0.97. What is the ratio of the Enrollment rate (%) of Ukraine in 2003 to that in 2007?
Offer a very short reply. 1. What is the ratio of the Enrollment rate (%) of Heavily indebted poor countries in 2003 to that in 2008?
Offer a terse response. 0.85. What is the ratio of the Enrollment rate (%) of Middle income in 2003 to that in 2008?
Ensure brevity in your answer.  0.98. What is the ratio of the Enrollment rate (%) in Ukraine in 2003 to that in 2008?
Provide a short and direct response. 1. What is the ratio of the Enrollment rate (%) of Heavily indebted poor countries in 2003 to that in 2009?
Ensure brevity in your answer.  0.85. What is the ratio of the Enrollment rate (%) in Middle income in 2003 to that in 2009?
Your response must be concise. 0.98. What is the ratio of the Enrollment rate (%) in Bolivia in 2003 to that in 2009?
Offer a terse response. 1.01. What is the ratio of the Enrollment rate (%) of Ukraine in 2003 to that in 2009?
Provide a succinct answer. 0.99. What is the ratio of the Enrollment rate (%) of Heavily indebted poor countries in 2003 to that in 2010?
Make the answer very short. 0.85. What is the ratio of the Enrollment rate (%) of Middle income in 2003 to that in 2010?
Your response must be concise. 0.97. What is the ratio of the Enrollment rate (%) of Bolivia in 2003 to that in 2010?
Offer a terse response. 1.04. What is the ratio of the Enrollment rate (%) of Ukraine in 2003 to that in 2010?
Keep it short and to the point. 0.96. What is the ratio of the Enrollment rate (%) in Heavily indebted poor countries in 2006 to that in 2007?
Your response must be concise. 0.98. What is the ratio of the Enrollment rate (%) in Middle income in 2006 to that in 2007?
Provide a succinct answer. 0.99. What is the ratio of the Enrollment rate (%) in Bolivia in 2006 to that in 2007?
Provide a succinct answer. 1.01. What is the ratio of the Enrollment rate (%) of Heavily indebted poor countries in 2006 to that in 2008?
Your answer should be very brief. 0.94. What is the ratio of the Enrollment rate (%) in Middle income in 2006 to that in 2008?
Give a very brief answer. 0.99. What is the ratio of the Enrollment rate (%) in Heavily indebted poor countries in 2006 to that in 2009?
Keep it short and to the point. 0.94. What is the ratio of the Enrollment rate (%) of Middle income in 2006 to that in 2009?
Your response must be concise. 0.99. What is the ratio of the Enrollment rate (%) of Bolivia in 2006 to that in 2009?
Your answer should be compact. 1.02. What is the ratio of the Enrollment rate (%) in Heavily indebted poor countries in 2006 to that in 2010?
Offer a terse response. 0.93. What is the ratio of the Enrollment rate (%) of Middle income in 2006 to that in 2010?
Provide a succinct answer. 0.99. What is the ratio of the Enrollment rate (%) in Bolivia in 2006 to that in 2010?
Keep it short and to the point. 1.05. What is the ratio of the Enrollment rate (%) of Heavily indebted poor countries in 2007 to that in 2008?
Provide a succinct answer. 0.96. What is the ratio of the Enrollment rate (%) in Middle income in 2007 to that in 2008?
Keep it short and to the point. 1.01. What is the ratio of the Enrollment rate (%) of Bolivia in 2007 to that in 2008?
Offer a terse response. 1.03. What is the ratio of the Enrollment rate (%) of Heavily indebted poor countries in 2007 to that in 2009?
Provide a short and direct response. 0.96. What is the ratio of the Enrollment rate (%) in Middle income in 2007 to that in 2009?
Keep it short and to the point. 1.01. What is the ratio of the Enrollment rate (%) in Bolivia in 2007 to that in 2009?
Make the answer very short. 1.01. What is the ratio of the Enrollment rate (%) of Heavily indebted poor countries in 2007 to that in 2010?
Ensure brevity in your answer.  0.96. What is the ratio of the Enrollment rate (%) in Bolivia in 2007 to that in 2010?
Ensure brevity in your answer.  1.04. What is the ratio of the Enrollment rate (%) in Ukraine in 2007 to that in 2010?
Ensure brevity in your answer.  0.96. What is the ratio of the Enrollment rate (%) in Heavily indebted poor countries in 2008 to that in 2009?
Offer a terse response. 1. What is the ratio of the Enrollment rate (%) of Bolivia in 2008 to that in 2009?
Your response must be concise. 0.98. What is the ratio of the Enrollment rate (%) in Ukraine in 2008 to that in 2009?
Offer a very short reply. 0.99. What is the ratio of the Enrollment rate (%) in Middle income in 2008 to that in 2010?
Give a very brief answer. 1. What is the ratio of the Enrollment rate (%) in Bolivia in 2008 to that in 2010?
Your answer should be very brief. 1.01. What is the ratio of the Enrollment rate (%) of Ukraine in 2008 to that in 2010?
Make the answer very short. 0.95. What is the ratio of the Enrollment rate (%) of Middle income in 2009 to that in 2010?
Give a very brief answer. 1. What is the ratio of the Enrollment rate (%) in Bolivia in 2009 to that in 2010?
Your response must be concise. 1.03. What is the ratio of the Enrollment rate (%) of Ukraine in 2009 to that in 2010?
Offer a terse response. 0.97. What is the difference between the highest and the second highest Enrollment rate (%) of Heavily indebted poor countries?
Ensure brevity in your answer.  0.15. What is the difference between the highest and the second highest Enrollment rate (%) of Middle income?
Provide a short and direct response. 0.35. What is the difference between the highest and the second highest Enrollment rate (%) in Bolivia?
Provide a short and direct response. 0.93. What is the difference between the highest and the second highest Enrollment rate (%) of Ukraine?
Your answer should be very brief. 0.87. What is the difference between the highest and the lowest Enrollment rate (%) in Heavily indebted poor countries?
Your response must be concise. 14.6. What is the difference between the highest and the lowest Enrollment rate (%) in Middle income?
Provide a succinct answer. 3.16. What is the difference between the highest and the lowest Enrollment rate (%) of Bolivia?
Give a very brief answer. 4.63. What is the difference between the highest and the lowest Enrollment rate (%) in Ukraine?
Offer a very short reply. 5.13. 